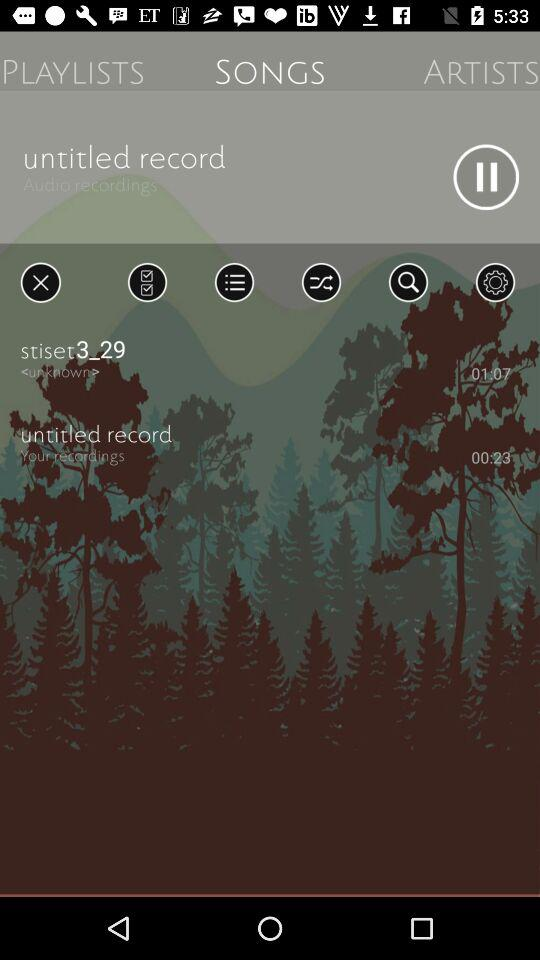What song has a length of 01:07? The song is "stiset3_29". 